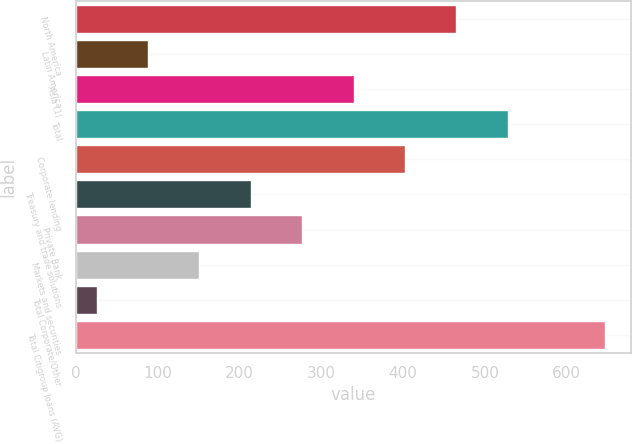Convert chart. <chart><loc_0><loc_0><loc_500><loc_500><bar_chart><fcel>North America<fcel>Latin America<fcel>Asia (1)<fcel>Total<fcel>Corporate lending<fcel>Treasury and trade solutions<fcel>Private Bank<fcel>Markets and securities<fcel>Total Corporate/Other<fcel>Total Citigroup loans (AVG)<nl><fcel>464.98<fcel>88.54<fcel>339.5<fcel>527.72<fcel>402.24<fcel>214.02<fcel>276.76<fcel>151.28<fcel>25.8<fcel>646.3<nl></chart> 